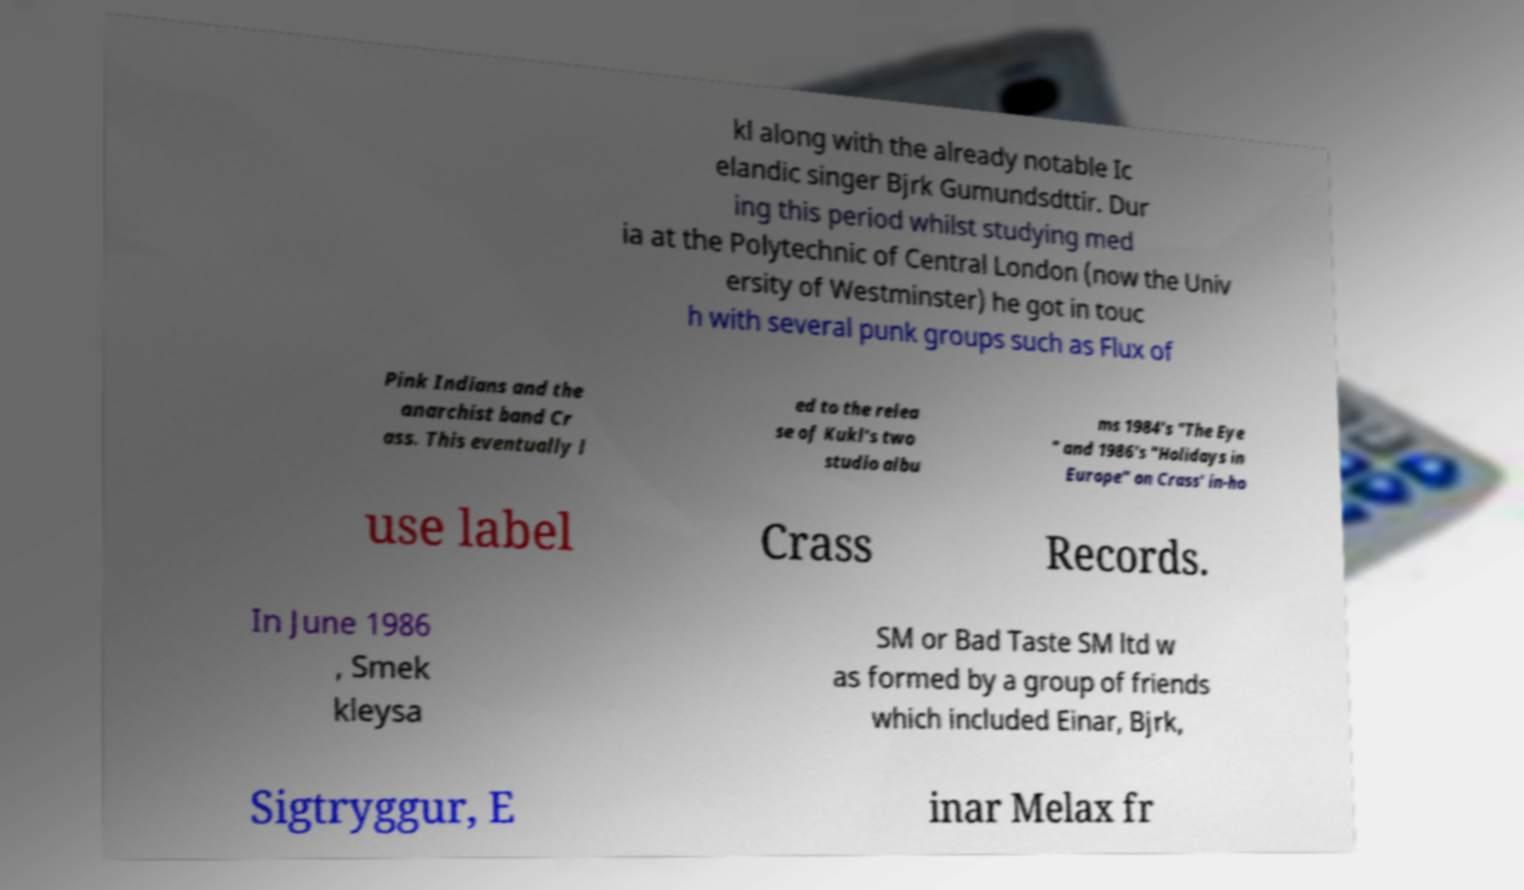Can you read and provide the text displayed in the image?This photo seems to have some interesting text. Can you extract and type it out for me? kl along with the already notable Ic elandic singer Bjrk Gumundsdttir. Dur ing this period whilst studying med ia at the Polytechnic of Central London (now the Univ ersity of Westminster) he got in touc h with several punk groups such as Flux of Pink Indians and the anarchist band Cr ass. This eventually l ed to the relea se of Kukl's two studio albu ms 1984's "The Eye " and 1986's "Holidays in Europe" on Crass' in-ho use label Crass Records. In June 1986 , Smek kleysa SM or Bad Taste SM ltd w as formed by a group of friends which included Einar, Bjrk, Sigtryggur, E inar Melax fr 